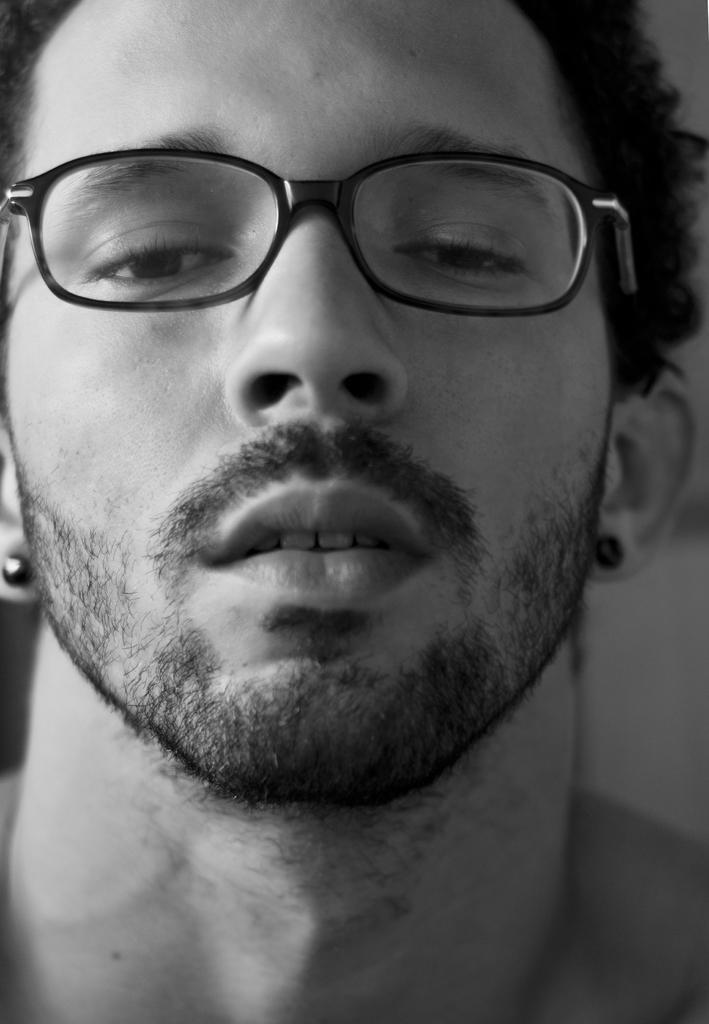Could you give a brief overview of what you see in this image? There is a black and white image. In this image, there is a person wearing spectacles. 